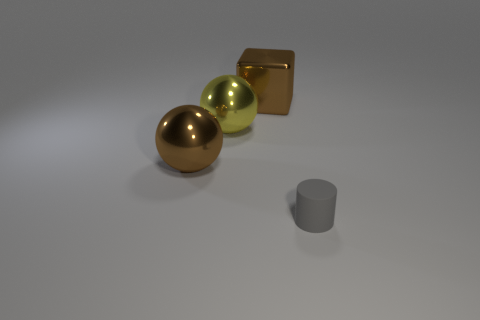What shape is the object that is both behind the gray cylinder and to the right of the yellow object? cube 